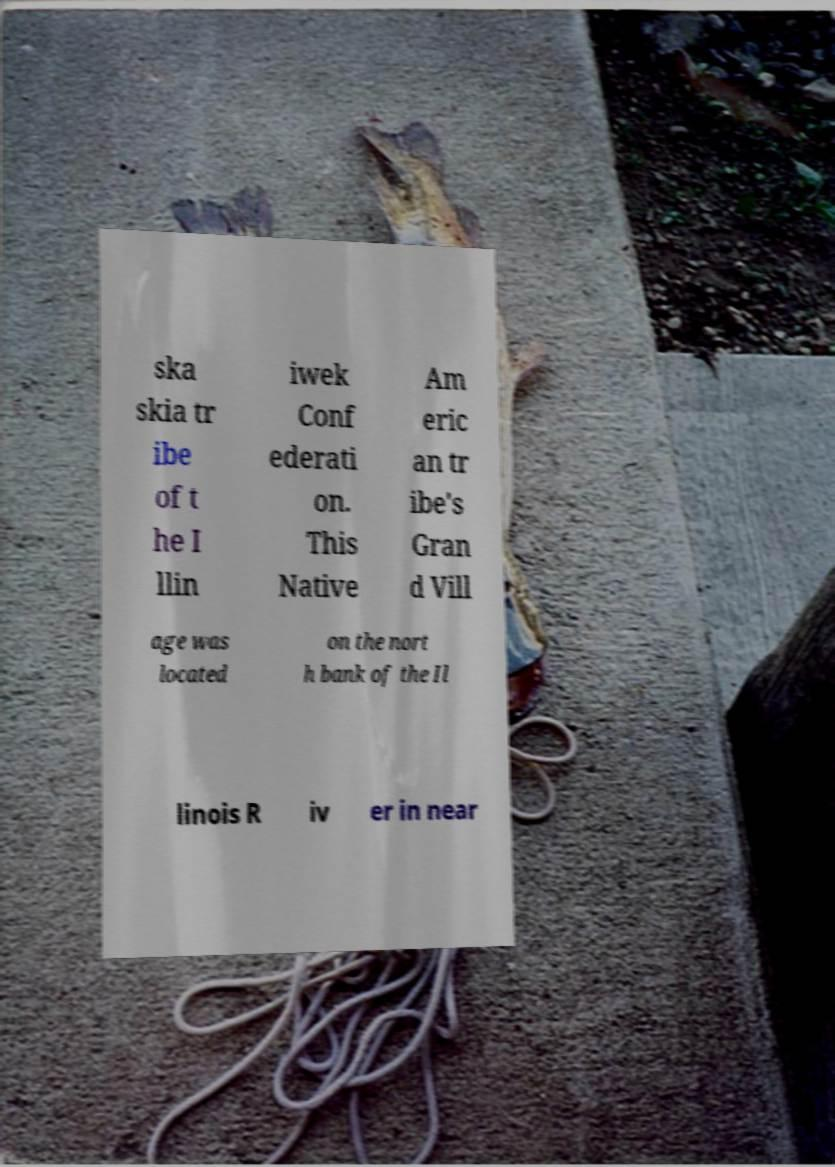There's text embedded in this image that I need extracted. Can you transcribe it verbatim? ska skia tr ibe of t he I llin iwek Conf ederati on. This Native Am eric an tr ibe's Gran d Vill age was located on the nort h bank of the Il linois R iv er in near 